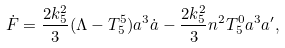<formula> <loc_0><loc_0><loc_500><loc_500>\dot { F } = \frac { 2 k ^ { 2 } _ { 5 } } { 3 } ( \Lambda - T _ { 5 } ^ { 5 } ) a ^ { 3 } \dot { a } - \frac { 2 k ^ { 2 } _ { 5 } } { 3 } n ^ { 2 } T _ { 5 } ^ { 0 } a ^ { 3 } a ^ { \prime } ,</formula> 